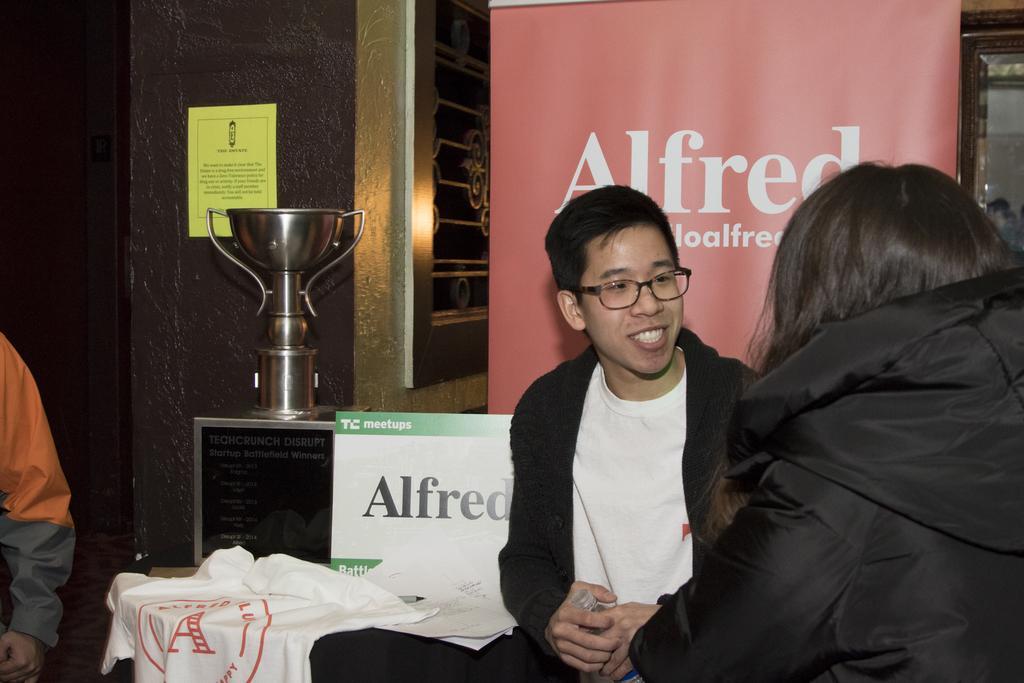In one or two sentences, can you explain what this image depicts? In this image on the right side there are two people, one person is smiling and he is holding a bottle. And on the left side there is another person and some t-shirts, cup and some boards. On the boards there is text, and in the background we could see a wall, and poster. On the poster there is text. 